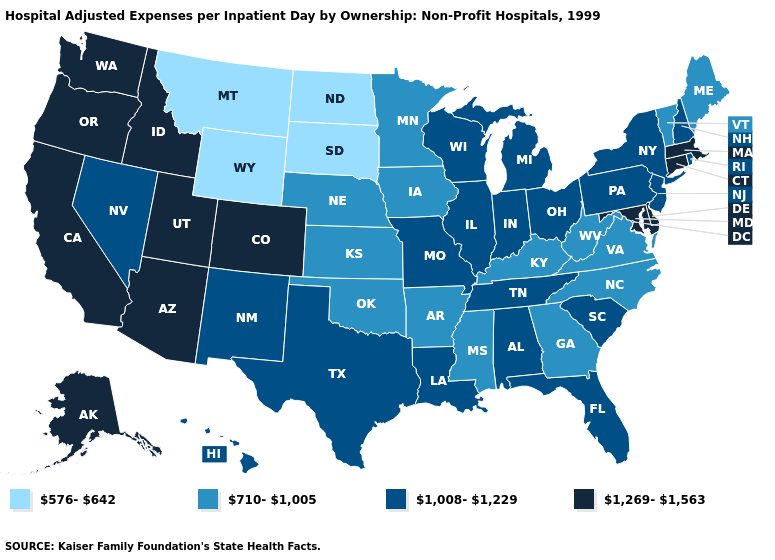What is the highest value in the USA?
Answer briefly. 1,269-1,563. Name the states that have a value in the range 1,008-1,229?
Be succinct. Alabama, Florida, Hawaii, Illinois, Indiana, Louisiana, Michigan, Missouri, Nevada, New Hampshire, New Jersey, New Mexico, New York, Ohio, Pennsylvania, Rhode Island, South Carolina, Tennessee, Texas, Wisconsin. What is the value of Wyoming?
Keep it brief. 576-642. Name the states that have a value in the range 710-1,005?
Give a very brief answer. Arkansas, Georgia, Iowa, Kansas, Kentucky, Maine, Minnesota, Mississippi, Nebraska, North Carolina, Oklahoma, Vermont, Virginia, West Virginia. How many symbols are there in the legend?
Be succinct. 4. Name the states that have a value in the range 1,008-1,229?
Short answer required. Alabama, Florida, Hawaii, Illinois, Indiana, Louisiana, Michigan, Missouri, Nevada, New Hampshire, New Jersey, New Mexico, New York, Ohio, Pennsylvania, Rhode Island, South Carolina, Tennessee, Texas, Wisconsin. What is the lowest value in the USA?
Concise answer only. 576-642. How many symbols are there in the legend?
Be succinct. 4. What is the lowest value in the USA?
Write a very short answer. 576-642. What is the value of Wyoming?
Write a very short answer. 576-642. Name the states that have a value in the range 1,008-1,229?
Keep it brief. Alabama, Florida, Hawaii, Illinois, Indiana, Louisiana, Michigan, Missouri, Nevada, New Hampshire, New Jersey, New Mexico, New York, Ohio, Pennsylvania, Rhode Island, South Carolina, Tennessee, Texas, Wisconsin. Among the states that border Wyoming , which have the lowest value?
Write a very short answer. Montana, South Dakota. Does North Dakota have the highest value in the MidWest?
Quick response, please. No. Which states have the lowest value in the South?
Be succinct. Arkansas, Georgia, Kentucky, Mississippi, North Carolina, Oklahoma, Virginia, West Virginia. 